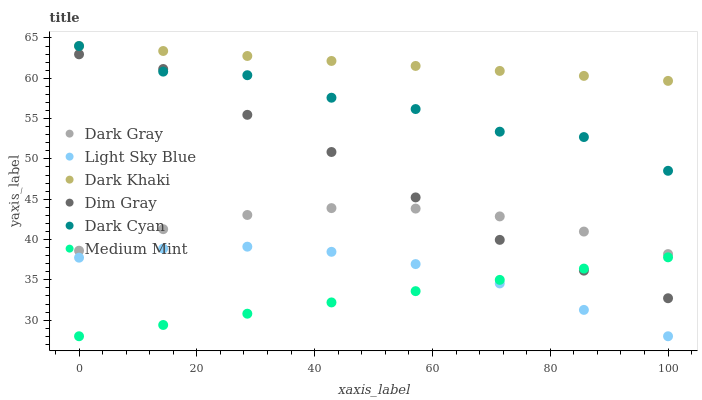Does Medium Mint have the minimum area under the curve?
Answer yes or no. Yes. Does Dark Khaki have the maximum area under the curve?
Answer yes or no. Yes. Does Dim Gray have the minimum area under the curve?
Answer yes or no. No. Does Dim Gray have the maximum area under the curve?
Answer yes or no. No. Is Dark Khaki the smoothest?
Answer yes or no. Yes. Is Dark Cyan the roughest?
Answer yes or no. Yes. Is Dim Gray the smoothest?
Answer yes or no. No. Is Dim Gray the roughest?
Answer yes or no. No. Does Medium Mint have the lowest value?
Answer yes or no. Yes. Does Dim Gray have the lowest value?
Answer yes or no. No. Does Dark Cyan have the highest value?
Answer yes or no. Yes. Does Dim Gray have the highest value?
Answer yes or no. No. Is Light Sky Blue less than Dark Gray?
Answer yes or no. Yes. Is Dark Khaki greater than Dim Gray?
Answer yes or no. Yes. Does Dark Cyan intersect Dark Khaki?
Answer yes or no. Yes. Is Dark Cyan less than Dark Khaki?
Answer yes or no. No. Is Dark Cyan greater than Dark Khaki?
Answer yes or no. No. Does Light Sky Blue intersect Dark Gray?
Answer yes or no. No. 